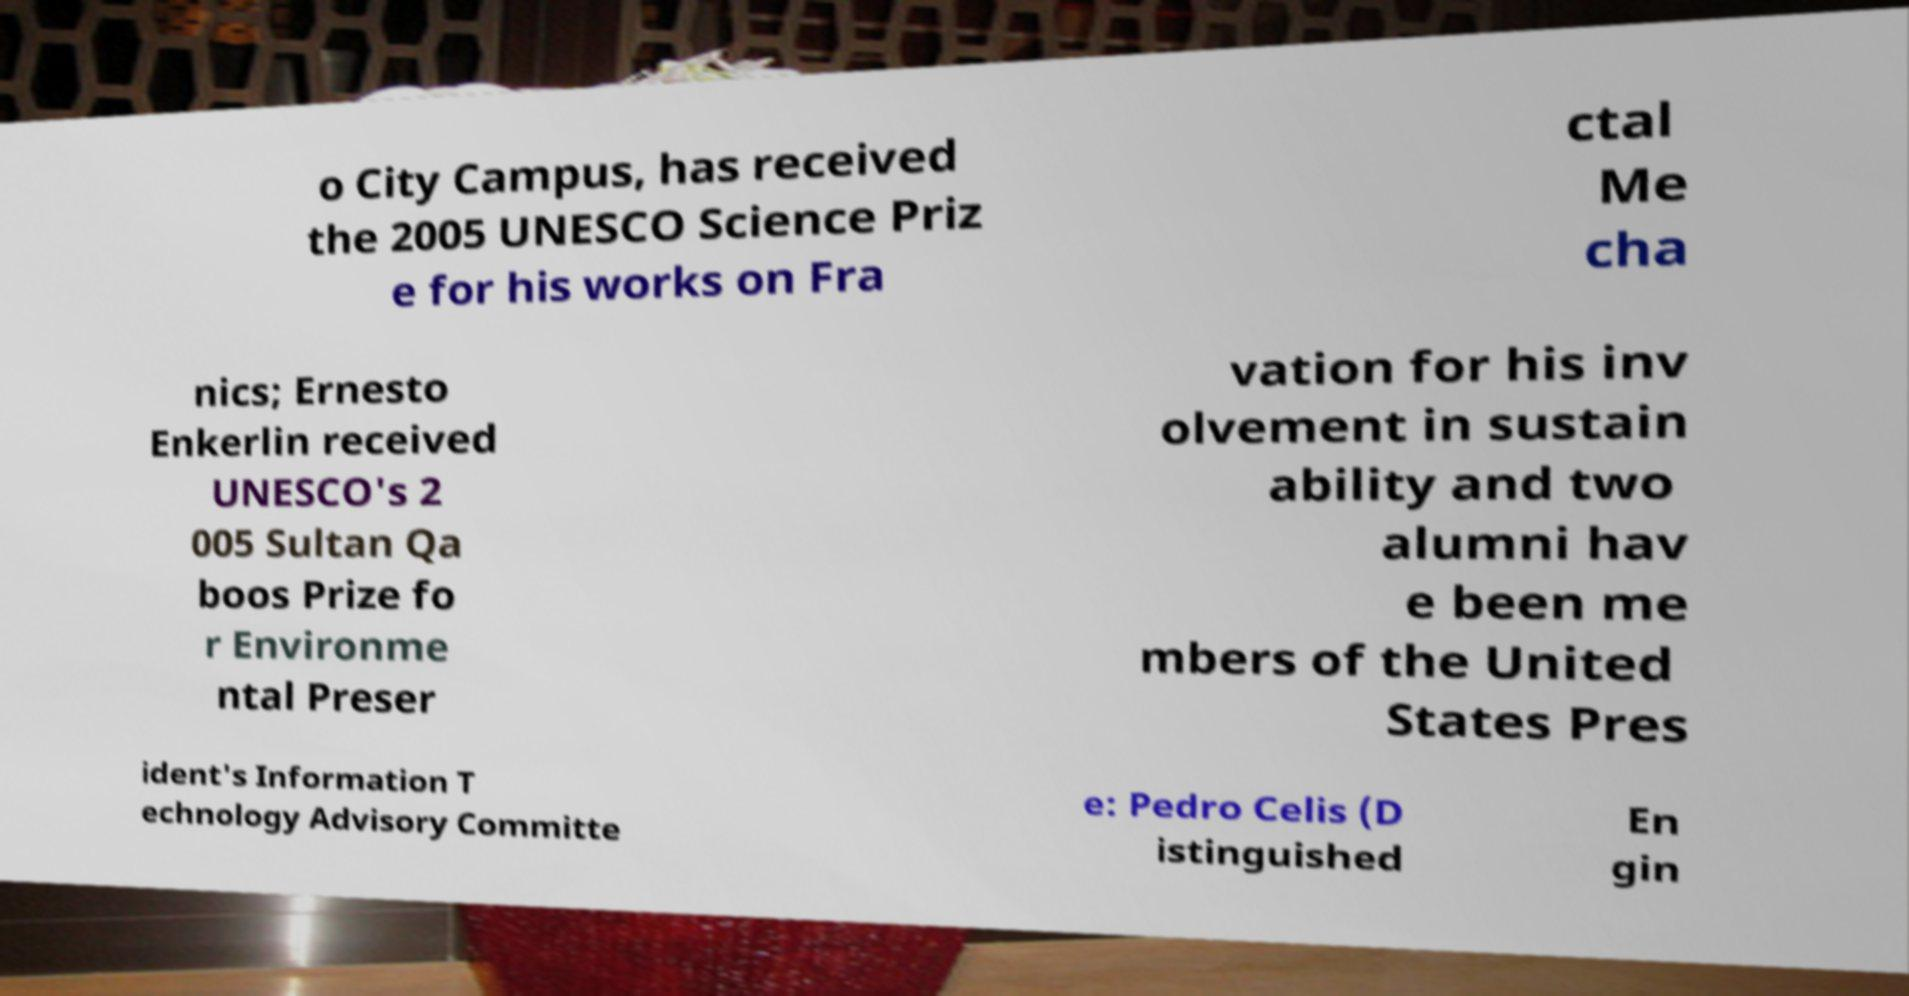Could you assist in decoding the text presented in this image and type it out clearly? o City Campus, has received the 2005 UNESCO Science Priz e for his works on Fra ctal Me cha nics; Ernesto Enkerlin received UNESCO's 2 005 Sultan Qa boos Prize fo r Environme ntal Preser vation for his inv olvement in sustain ability and two alumni hav e been me mbers of the United States Pres ident's Information T echnology Advisory Committe e: Pedro Celis (D istinguished En gin 